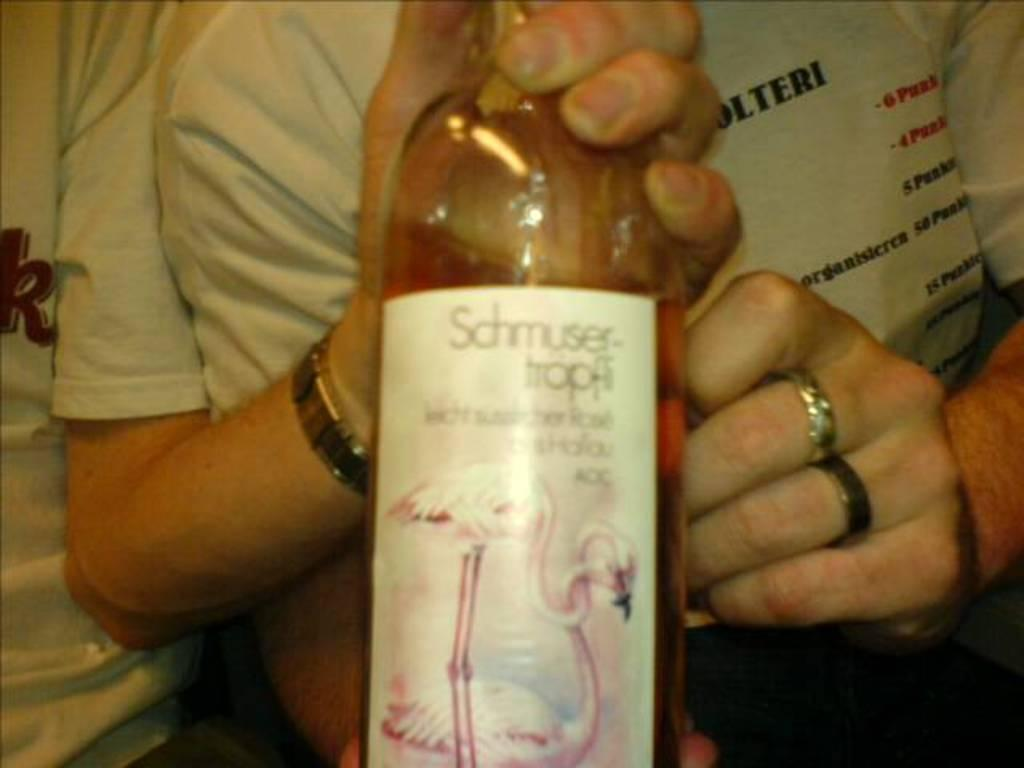Provide a one-sentence caption for the provided image. a new bottle of scmusertrpfi with a flamingo displayed. 